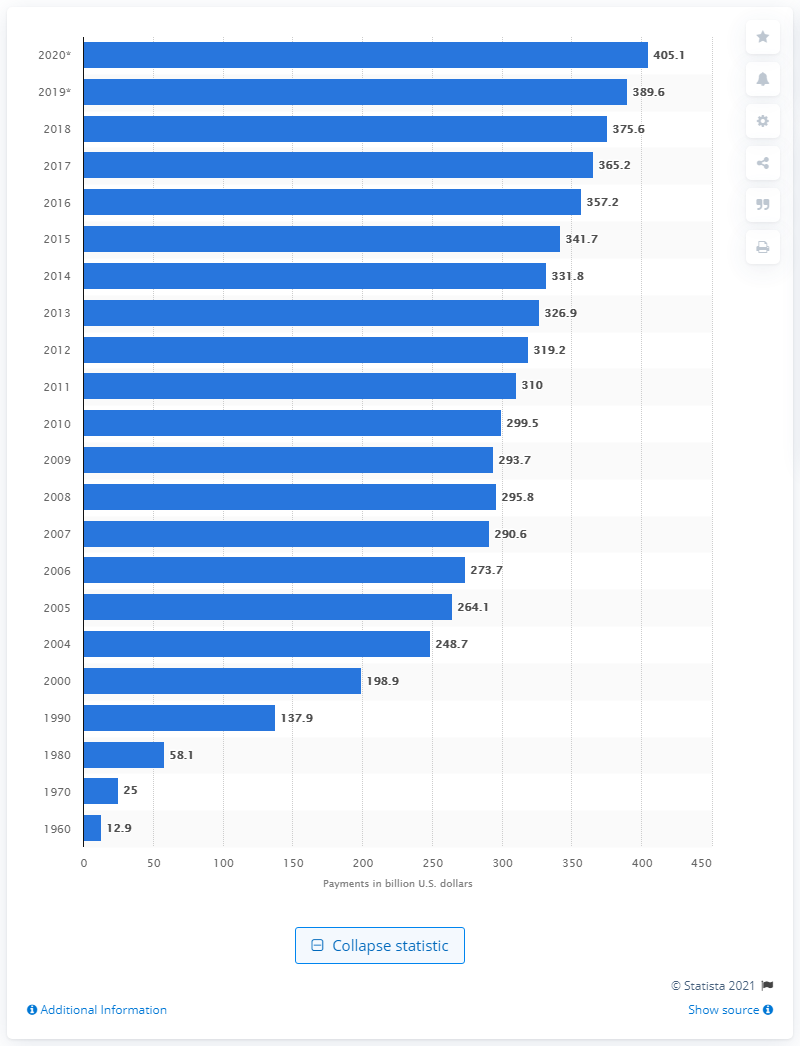Specify some key components in this picture. The estimated amount of out-of-pocket health care payments in the United States in 2020 is 405.1. 